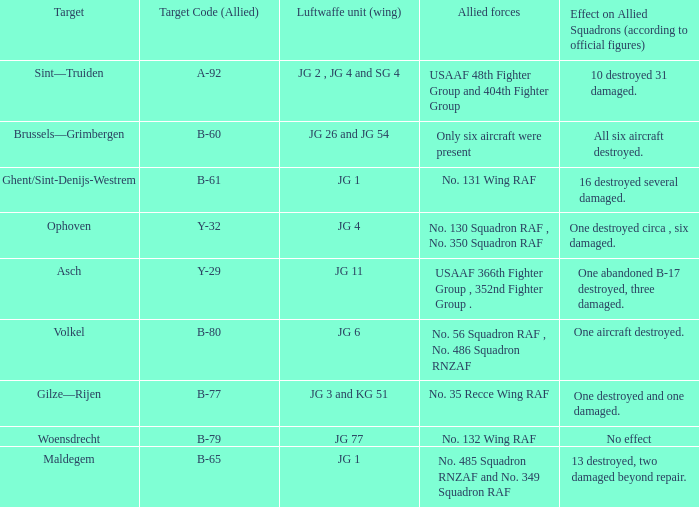Which Allied Force targetted Woensdrecht? No. 132 Wing RAF. 